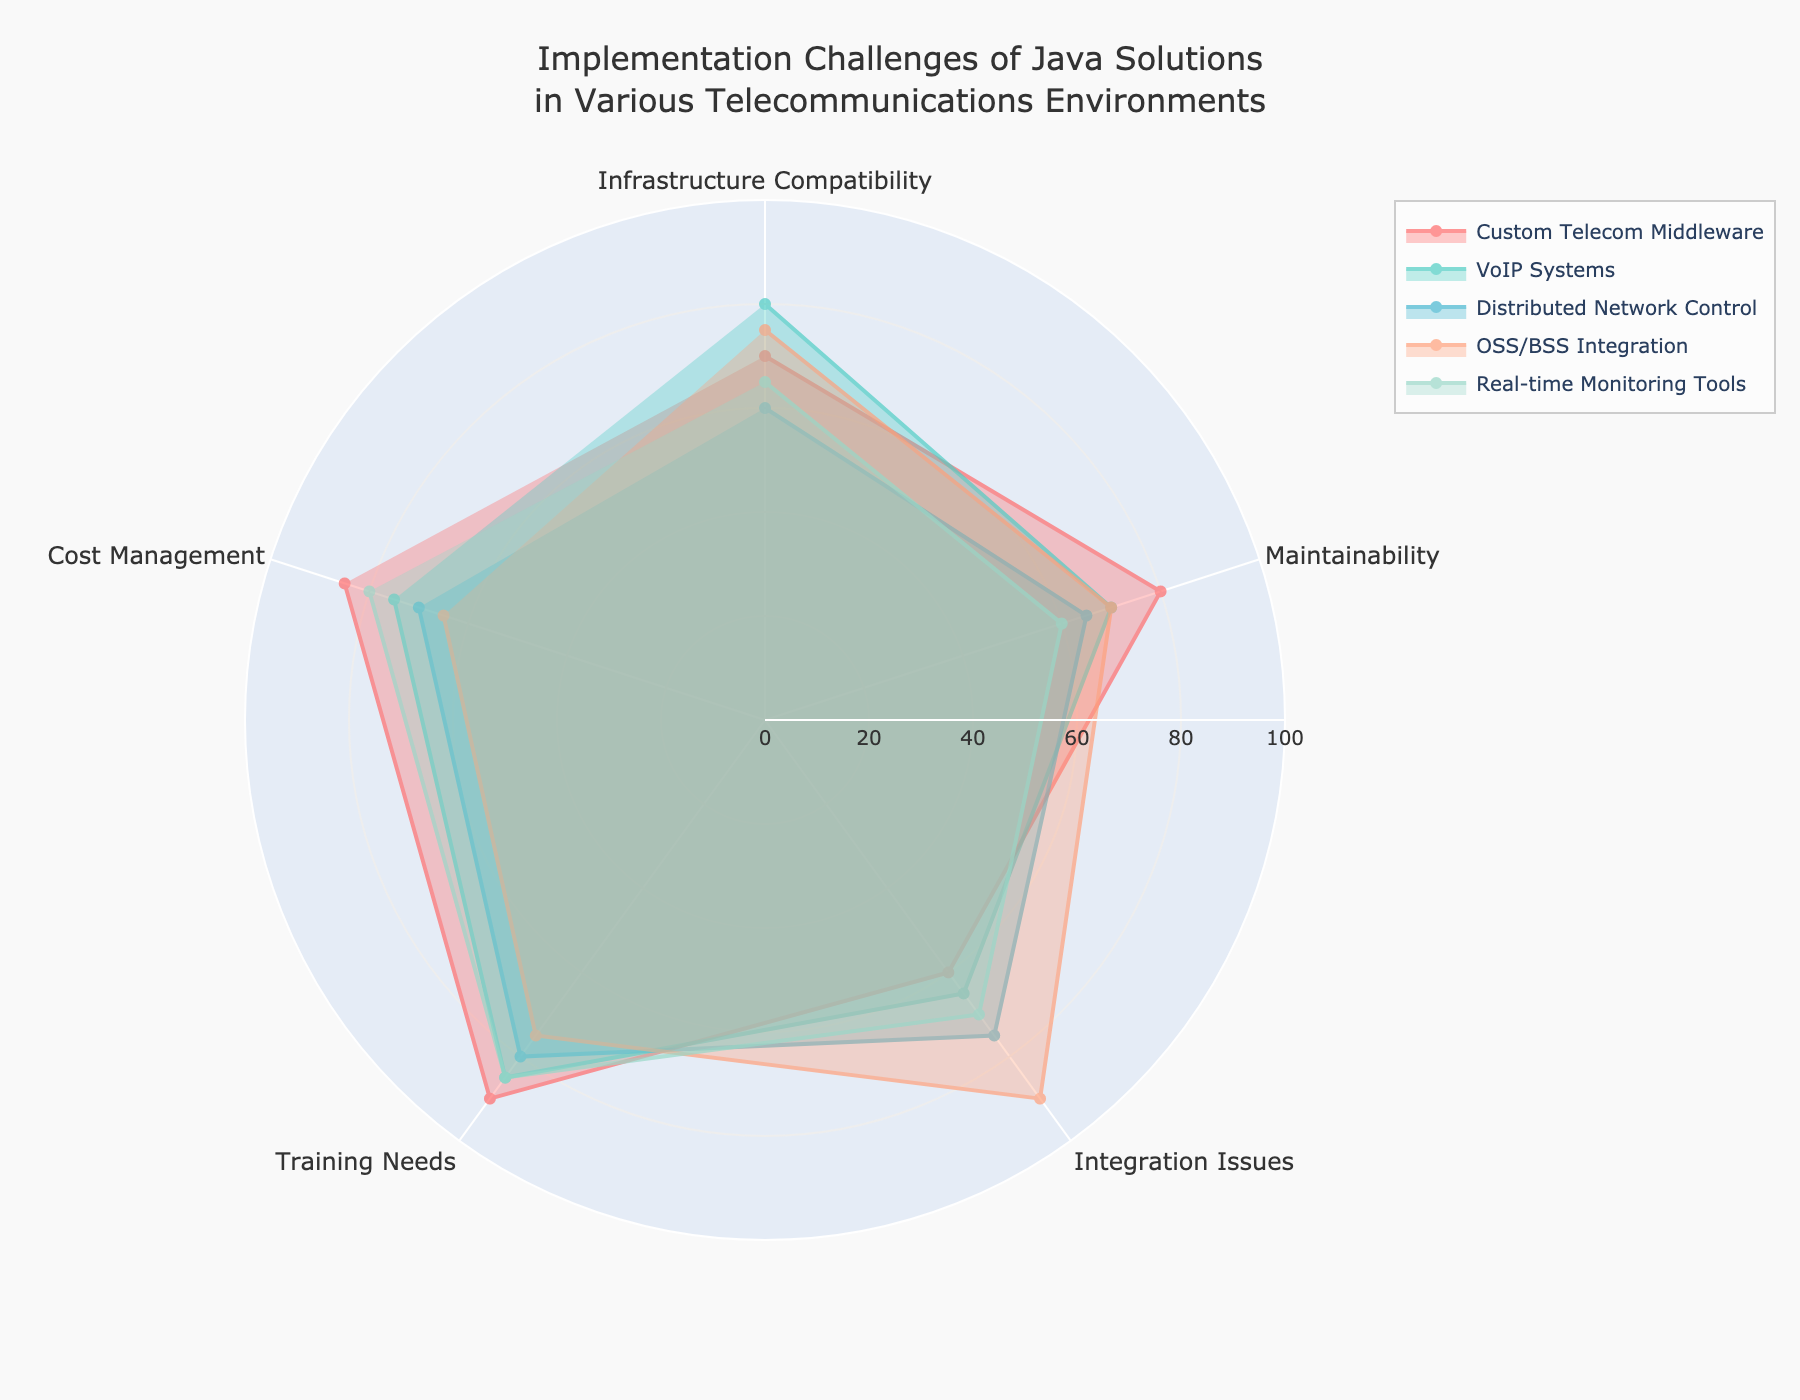What is the title of the radar chart? The title of the radar chart is displayed at the top center of the figure, usually providing a summary of what the chart represents.
Answer: Implementation Challenges of Java Solutions in Various Telecommunications Environments Which category shows the highest level of 'Integration Issues'? By comparing the 'Integration Issues' values for each category, the category with the highest value is determined.
Answer: OSS/BSS Integration What is the average score for 'Training Needs' across all categories? First, list the 'Training Needs' values for all categories: 90, 85, 80, 75, 85. Then sum these values and divide by the number of categories (5). (90 + 85 + 80 + 75 + 85) / 5 = 415 / 5 = 83
Answer: 83 Which categories have 'Maintainability' scores higher than 70? By inspecting the 'Maintainability' scores, categories with scores greater than 70 are identified. These categories are Custom Telecom Middleware and VoIP Systems.
Answer: Custom Telecom Middleware, VoIP Systems How does 'Custom Telecom Middleware' compare to 'Real-time Monitoring Tools' in 'Cost Management'? By comparing the 'Cost Management' scores, Custom Telecom Middleware has a score of 85, while Real-Time Monitoring Tools has a score of 80. Therefore, Custom Telecom Middleware has a higher score.
Answer: Higher What is the range of values for 'Infrastructure Compatibility'? The 'Infrastructure Compatibility' scores vary from 60 (Distributed Network Control) to 80 (VoIP Systems). The range is the difference between the maximum and minimum values: 80 - 60 = 20
Answer: 20 What is the second highest score for 'Maintainability'? By ordering the 'Maintainability' scores, the second highest score can be found. These scores are 80, 70, 65, 70, and 60. The second highest score is 70.
Answer: 70 What is the combined score of all categories for 'Cost Management'? Sum the 'Cost Management' scores for all categories: 85 (Custom Telecom Middleware) + 75 (VoIP Systems) + 70 (Distributed Network Control) + 65 (OSS/BSS Integration) + 80 (Real-time Monitoring Tools). Total: 85 + 75 + 70 + 65 + 80 = 375
Answer: 375 Which category has the most even distribution of implementation challenge scores? To find the category with the most even distribution, look for the category where the scores are closest to one another. Custom Telecom Middleware has scores of 70, 80, 60, 90, and 85, while others have more variation. Thus, inspect other categories, and compare. Real-Time Monitoring Tools have a closer distribution: 65, 60, 70, 85, 80.
Answer: Real-time Monitoring Tools 